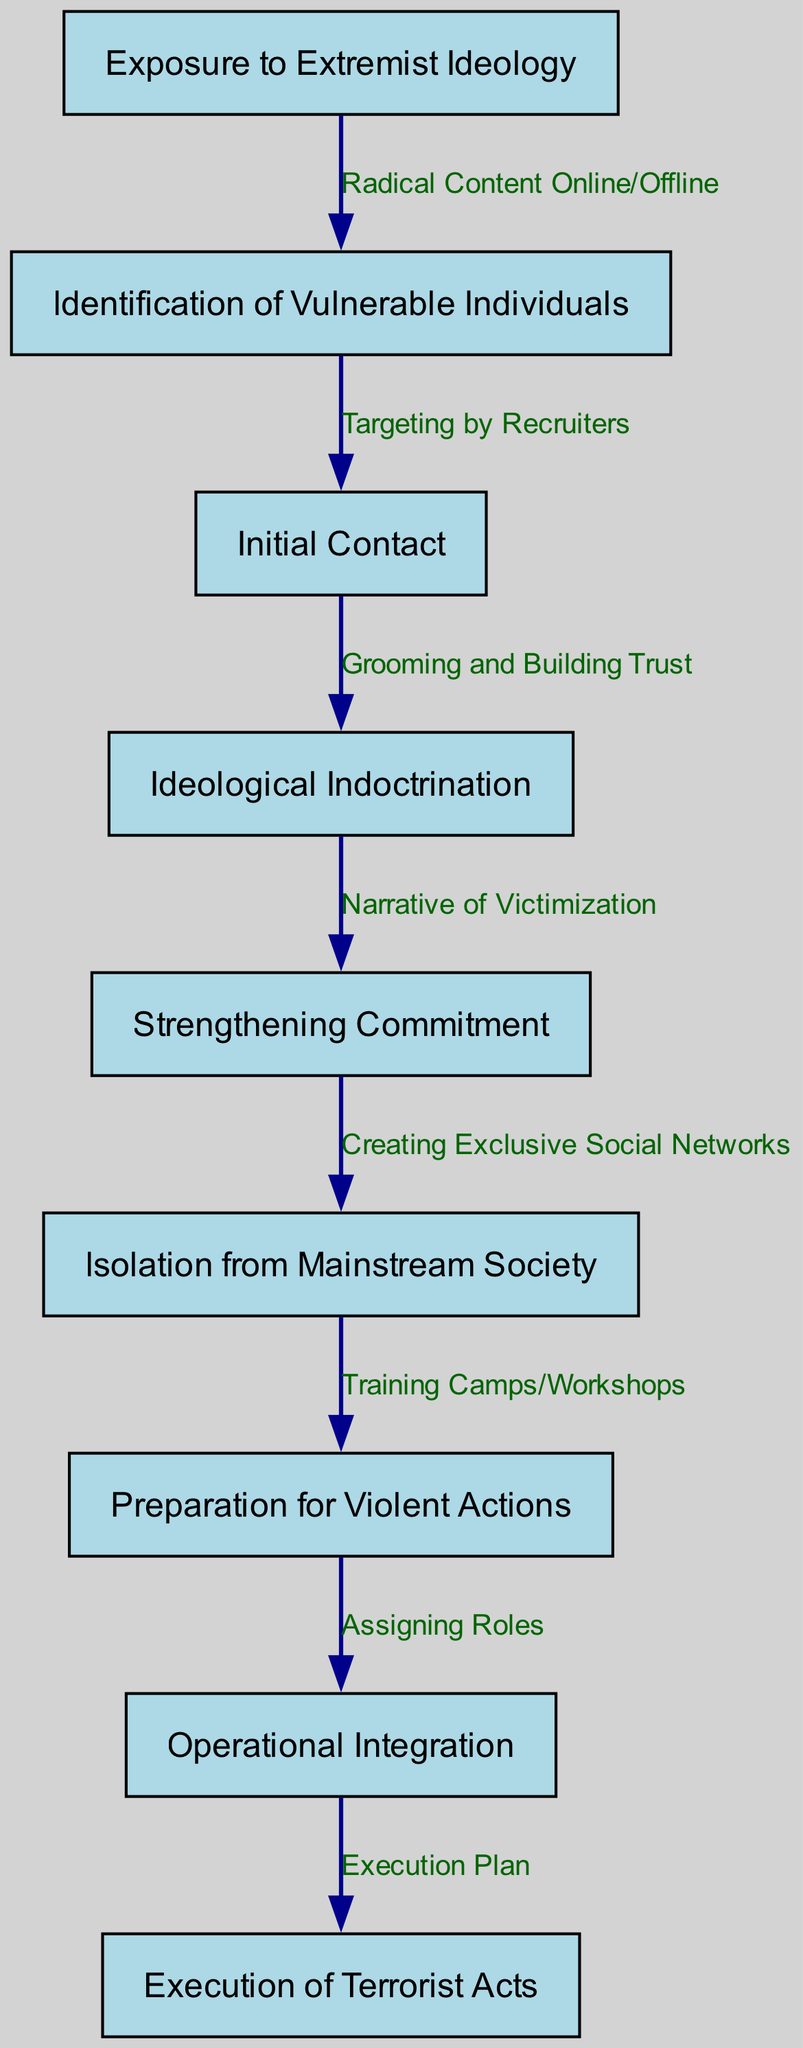What is the first step in the recruitment pathway? The first step in the recruitment pathway is "Exposure to Extremist Ideology," which is the starting point that leads to further stages in the terrorist recruitment process.
Answer: Exposure to Extremist Ideology What is the last step in the process? The last step in the process is "Execution of Terrorist Acts," which concludes the sequence of actions associated with recruitment and operation integration.
Answer: Execution of Terrorist Acts How many nodes are in the diagram? The diagram contains a total of nine nodes, each representing a key step in the recruitment pathway.
Answer: Nine What type of relationship exists between "Preparation for Violent Actions" and "Operational Integration"? The relationship between "Preparation for Violent Actions" and "Operational Integration" is described as "Assigning Roles," indicating that roles are allocated in this stage following the preparation for violence.
Answer: Assigning Roles Identify the node that follows "Strengthening Commitment." The node that follows "Strengthening Commitment" is "Isolation from Mainstream Society," marking a transition that emphasizes the separation of recruits from broader society.
Answer: Isolation from Mainstream Society How are vulnerable individuals identified? Vulnerable individuals are identified through "Targeting by Recruiters," a deliberate action that follows the initial identification process after exposure to extremist ideology.
Answer: Targeting by Recruiters What step comes before "Grooming and Building Trust"? The step that comes before "Grooming and Building Trust" is "Initial Contact," which signifies the first engagement with potential recruits in the process.
Answer: Initial Contact How does "Ideological Indoctrination" connect to the overall process? "Ideological Indoctrination" connects to the overall process as it is a critical step that follows the "Initial Contact" and is essential for deepening the recruits' commitment to extremist views.
Answer: It deepens commitment What is necessary for the transition from "Isolation from Mainstream Society" to "Preparation for Violent Actions"? The transition requires "Training Camps/Workshops," which provide the necessary skills and environment for potential terrorists to prepare for violence following their isolation.
Answer: Training Camps/Workshops 